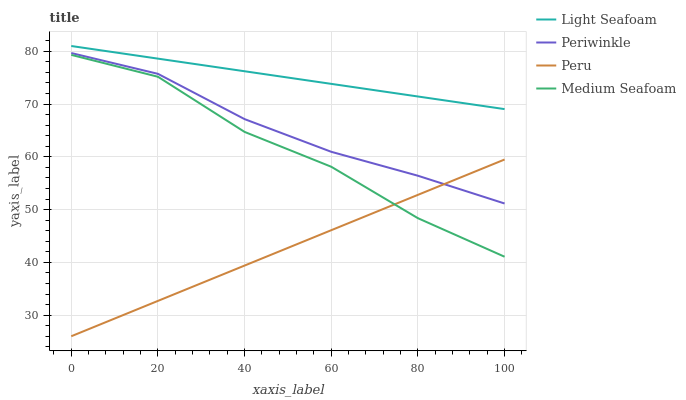Does Peru have the minimum area under the curve?
Answer yes or no. Yes. Does Light Seafoam have the maximum area under the curve?
Answer yes or no. Yes. Does Periwinkle have the minimum area under the curve?
Answer yes or no. No. Does Periwinkle have the maximum area under the curve?
Answer yes or no. No. Is Peru the smoothest?
Answer yes or no. Yes. Is Medium Seafoam the roughest?
Answer yes or no. Yes. Is Periwinkle the smoothest?
Answer yes or no. No. Is Periwinkle the roughest?
Answer yes or no. No. Does Peru have the lowest value?
Answer yes or no. Yes. Does Periwinkle have the lowest value?
Answer yes or no. No. Does Light Seafoam have the highest value?
Answer yes or no. Yes. Does Periwinkle have the highest value?
Answer yes or no. No. Is Medium Seafoam less than Periwinkle?
Answer yes or no. Yes. Is Light Seafoam greater than Medium Seafoam?
Answer yes or no. Yes. Does Medium Seafoam intersect Peru?
Answer yes or no. Yes. Is Medium Seafoam less than Peru?
Answer yes or no. No. Is Medium Seafoam greater than Peru?
Answer yes or no. No. Does Medium Seafoam intersect Periwinkle?
Answer yes or no. No. 